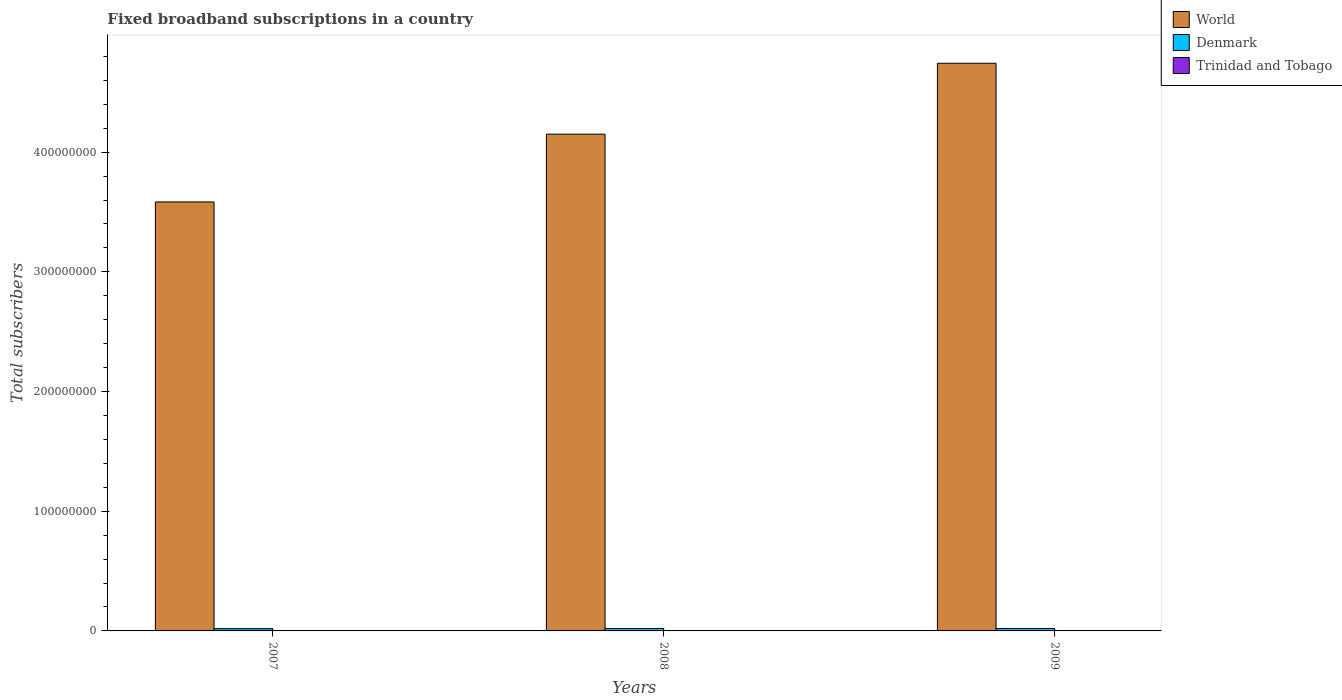How many bars are there on the 1st tick from the left?
Make the answer very short. 3. How many bars are there on the 1st tick from the right?
Your answer should be compact. 3. What is the label of the 2nd group of bars from the left?
Make the answer very short. 2008. In how many cases, is the number of bars for a given year not equal to the number of legend labels?
Your answer should be very brief. 0. What is the number of broadband subscriptions in Trinidad and Tobago in 2008?
Offer a terse response. 8.54e+04. Across all years, what is the maximum number of broadband subscriptions in World?
Provide a succinct answer. 4.74e+08. Across all years, what is the minimum number of broadband subscriptions in Denmark?
Make the answer very short. 1.90e+06. What is the total number of broadband subscriptions in World in the graph?
Offer a very short reply. 1.25e+09. What is the difference between the number of broadband subscriptions in World in 2007 and that in 2009?
Offer a very short reply. -1.16e+08. What is the difference between the number of broadband subscriptions in World in 2007 and the number of broadband subscriptions in Trinidad and Tobago in 2009?
Keep it short and to the point. 3.58e+08. What is the average number of broadband subscriptions in World per year?
Your response must be concise. 4.16e+08. In the year 2007, what is the difference between the number of broadband subscriptions in World and number of broadband subscriptions in Trinidad and Tobago?
Your answer should be very brief. 3.58e+08. In how many years, is the number of broadband subscriptions in Trinidad and Tobago greater than 120000000?
Give a very brief answer. 0. What is the ratio of the number of broadband subscriptions in Denmark in 2007 to that in 2008?
Offer a terse response. 0.95. Is the difference between the number of broadband subscriptions in World in 2008 and 2009 greater than the difference between the number of broadband subscriptions in Trinidad and Tobago in 2008 and 2009?
Offer a terse response. No. What is the difference between the highest and the second highest number of broadband subscriptions in Denmark?
Provide a succinct answer. 1.70e+04. What is the difference between the highest and the lowest number of broadband subscriptions in Denmark?
Your answer should be compact. 1.19e+05. Is the sum of the number of broadband subscriptions in World in 2007 and 2009 greater than the maximum number of broadband subscriptions in Denmark across all years?
Provide a short and direct response. Yes. What does the 3rd bar from the left in 2008 represents?
Give a very brief answer. Trinidad and Tobago. What does the 1st bar from the right in 2008 represents?
Your answer should be very brief. Trinidad and Tobago. Are all the bars in the graph horizontal?
Provide a short and direct response. No. How many years are there in the graph?
Offer a terse response. 3. Are the values on the major ticks of Y-axis written in scientific E-notation?
Provide a succinct answer. No. Where does the legend appear in the graph?
Keep it short and to the point. Top right. How are the legend labels stacked?
Your answer should be compact. Vertical. What is the title of the graph?
Offer a very short reply. Fixed broadband subscriptions in a country. Does "Guam" appear as one of the legend labels in the graph?
Give a very brief answer. No. What is the label or title of the Y-axis?
Provide a succinct answer. Total subscribers. What is the Total subscribers in World in 2007?
Ensure brevity in your answer.  3.58e+08. What is the Total subscribers in Denmark in 2007?
Provide a succinct answer. 1.90e+06. What is the Total subscribers in Trinidad and Tobago in 2007?
Keep it short and to the point. 3.55e+04. What is the Total subscribers of World in 2008?
Keep it short and to the point. 4.15e+08. What is the Total subscribers in Denmark in 2008?
Your answer should be very brief. 2.01e+06. What is the Total subscribers of Trinidad and Tobago in 2008?
Your answer should be compact. 8.54e+04. What is the Total subscribers of World in 2009?
Offer a very short reply. 4.74e+08. What is the Total subscribers in Denmark in 2009?
Offer a terse response. 2.02e+06. What is the Total subscribers in Trinidad and Tobago in 2009?
Make the answer very short. 1.30e+05. Across all years, what is the maximum Total subscribers of World?
Ensure brevity in your answer.  4.74e+08. Across all years, what is the maximum Total subscribers in Denmark?
Your answer should be compact. 2.02e+06. Across all years, what is the maximum Total subscribers in Trinidad and Tobago?
Make the answer very short. 1.30e+05. Across all years, what is the minimum Total subscribers of World?
Provide a succinct answer. 3.58e+08. Across all years, what is the minimum Total subscribers in Denmark?
Your answer should be compact. 1.90e+06. Across all years, what is the minimum Total subscribers of Trinidad and Tobago?
Give a very brief answer. 3.55e+04. What is the total Total subscribers of World in the graph?
Provide a short and direct response. 1.25e+09. What is the total Total subscribers in Denmark in the graph?
Your response must be concise. 5.93e+06. What is the total Total subscribers in Trinidad and Tobago in the graph?
Keep it short and to the point. 2.51e+05. What is the difference between the Total subscribers in World in 2007 and that in 2008?
Offer a terse response. -5.66e+07. What is the difference between the Total subscribers of Denmark in 2007 and that in 2008?
Give a very brief answer. -1.02e+05. What is the difference between the Total subscribers of Trinidad and Tobago in 2007 and that in 2008?
Give a very brief answer. -5.00e+04. What is the difference between the Total subscribers of World in 2007 and that in 2009?
Offer a very short reply. -1.16e+08. What is the difference between the Total subscribers in Denmark in 2007 and that in 2009?
Ensure brevity in your answer.  -1.19e+05. What is the difference between the Total subscribers in Trinidad and Tobago in 2007 and that in 2009?
Provide a succinct answer. -9.46e+04. What is the difference between the Total subscribers in World in 2008 and that in 2009?
Your answer should be very brief. -5.92e+07. What is the difference between the Total subscribers of Denmark in 2008 and that in 2009?
Your answer should be very brief. -1.70e+04. What is the difference between the Total subscribers in Trinidad and Tobago in 2008 and that in 2009?
Make the answer very short. -4.46e+04. What is the difference between the Total subscribers in World in 2007 and the Total subscribers in Denmark in 2008?
Your response must be concise. 3.56e+08. What is the difference between the Total subscribers in World in 2007 and the Total subscribers in Trinidad and Tobago in 2008?
Provide a succinct answer. 3.58e+08. What is the difference between the Total subscribers of Denmark in 2007 and the Total subscribers of Trinidad and Tobago in 2008?
Keep it short and to the point. 1.82e+06. What is the difference between the Total subscribers in World in 2007 and the Total subscribers in Denmark in 2009?
Provide a short and direct response. 3.56e+08. What is the difference between the Total subscribers in World in 2007 and the Total subscribers in Trinidad and Tobago in 2009?
Keep it short and to the point. 3.58e+08. What is the difference between the Total subscribers in Denmark in 2007 and the Total subscribers in Trinidad and Tobago in 2009?
Your answer should be compact. 1.77e+06. What is the difference between the Total subscribers of World in 2008 and the Total subscribers of Denmark in 2009?
Give a very brief answer. 4.13e+08. What is the difference between the Total subscribers of World in 2008 and the Total subscribers of Trinidad and Tobago in 2009?
Provide a succinct answer. 4.15e+08. What is the difference between the Total subscribers of Denmark in 2008 and the Total subscribers of Trinidad and Tobago in 2009?
Keep it short and to the point. 1.88e+06. What is the average Total subscribers of World per year?
Give a very brief answer. 4.16e+08. What is the average Total subscribers in Denmark per year?
Offer a terse response. 1.98e+06. What is the average Total subscribers of Trinidad and Tobago per year?
Give a very brief answer. 8.37e+04. In the year 2007, what is the difference between the Total subscribers of World and Total subscribers of Denmark?
Your answer should be compact. 3.56e+08. In the year 2007, what is the difference between the Total subscribers of World and Total subscribers of Trinidad and Tobago?
Provide a short and direct response. 3.58e+08. In the year 2007, what is the difference between the Total subscribers in Denmark and Total subscribers in Trinidad and Tobago?
Provide a succinct answer. 1.87e+06. In the year 2008, what is the difference between the Total subscribers in World and Total subscribers in Denmark?
Ensure brevity in your answer.  4.13e+08. In the year 2008, what is the difference between the Total subscribers of World and Total subscribers of Trinidad and Tobago?
Keep it short and to the point. 4.15e+08. In the year 2008, what is the difference between the Total subscribers of Denmark and Total subscribers of Trinidad and Tobago?
Give a very brief answer. 1.92e+06. In the year 2009, what is the difference between the Total subscribers in World and Total subscribers in Denmark?
Give a very brief answer. 4.72e+08. In the year 2009, what is the difference between the Total subscribers in World and Total subscribers in Trinidad and Tobago?
Provide a succinct answer. 4.74e+08. In the year 2009, what is the difference between the Total subscribers in Denmark and Total subscribers in Trinidad and Tobago?
Offer a terse response. 1.89e+06. What is the ratio of the Total subscribers in World in 2007 to that in 2008?
Provide a succinct answer. 0.86. What is the ratio of the Total subscribers in Denmark in 2007 to that in 2008?
Ensure brevity in your answer.  0.95. What is the ratio of the Total subscribers of Trinidad and Tobago in 2007 to that in 2008?
Provide a succinct answer. 0.42. What is the ratio of the Total subscribers of World in 2007 to that in 2009?
Your answer should be very brief. 0.76. What is the ratio of the Total subscribers in Denmark in 2007 to that in 2009?
Provide a succinct answer. 0.94. What is the ratio of the Total subscribers of Trinidad and Tobago in 2007 to that in 2009?
Your response must be concise. 0.27. What is the ratio of the Total subscribers in World in 2008 to that in 2009?
Offer a terse response. 0.88. What is the ratio of the Total subscribers of Denmark in 2008 to that in 2009?
Make the answer very short. 0.99. What is the ratio of the Total subscribers in Trinidad and Tobago in 2008 to that in 2009?
Your response must be concise. 0.66. What is the difference between the highest and the second highest Total subscribers of World?
Make the answer very short. 5.92e+07. What is the difference between the highest and the second highest Total subscribers in Denmark?
Ensure brevity in your answer.  1.70e+04. What is the difference between the highest and the second highest Total subscribers of Trinidad and Tobago?
Make the answer very short. 4.46e+04. What is the difference between the highest and the lowest Total subscribers in World?
Offer a terse response. 1.16e+08. What is the difference between the highest and the lowest Total subscribers in Denmark?
Your answer should be very brief. 1.19e+05. What is the difference between the highest and the lowest Total subscribers in Trinidad and Tobago?
Your response must be concise. 9.46e+04. 